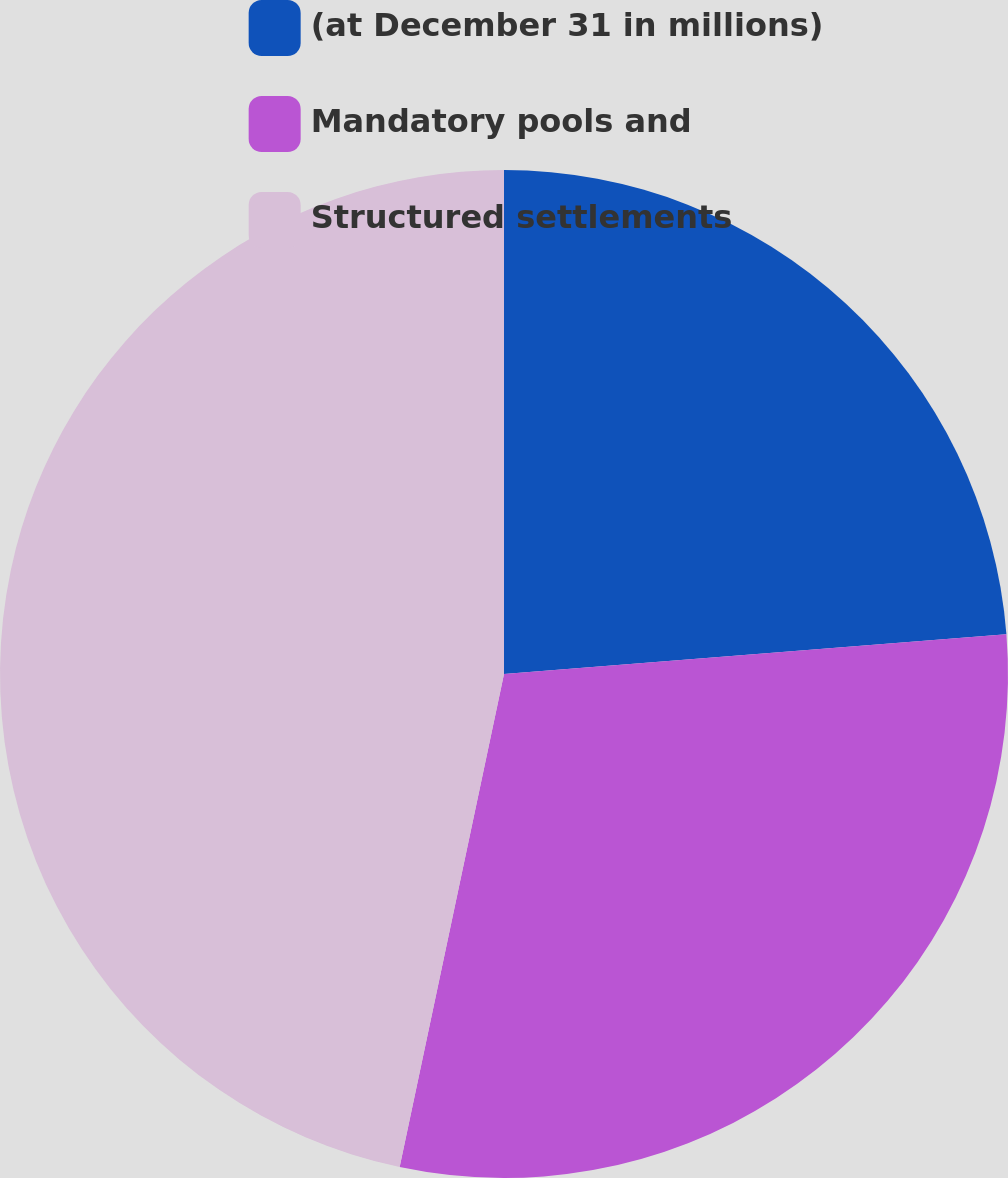Convert chart. <chart><loc_0><loc_0><loc_500><loc_500><pie_chart><fcel>(at December 31 in millions)<fcel>Mandatory pools and<fcel>Structured settlements<nl><fcel>23.74%<fcel>29.58%<fcel>46.68%<nl></chart> 